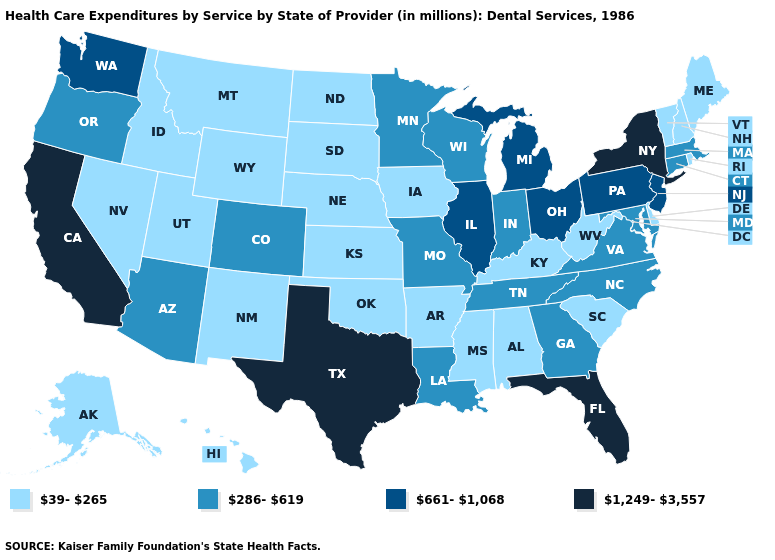Among the states that border Wisconsin , which have the lowest value?
Keep it brief. Iowa. Among the states that border Kentucky , which have the highest value?
Write a very short answer. Illinois, Ohio. Does Kansas have the highest value in the USA?
Give a very brief answer. No. Among the states that border South Dakota , does North Dakota have the lowest value?
Be succinct. Yes. What is the value of Arkansas?
Be succinct. 39-265. Among the states that border Wyoming , which have the lowest value?
Concise answer only. Idaho, Montana, Nebraska, South Dakota, Utah. Name the states that have a value in the range 661-1,068?
Short answer required. Illinois, Michigan, New Jersey, Ohio, Pennsylvania, Washington. Among the states that border Texas , does Louisiana have the lowest value?
Short answer required. No. Does Maine have a higher value than South Dakota?
Concise answer only. No. Which states have the lowest value in the West?
Be succinct. Alaska, Hawaii, Idaho, Montana, Nevada, New Mexico, Utah, Wyoming. Does Wisconsin have a lower value than Arkansas?
Short answer required. No. Name the states that have a value in the range 286-619?
Short answer required. Arizona, Colorado, Connecticut, Georgia, Indiana, Louisiana, Maryland, Massachusetts, Minnesota, Missouri, North Carolina, Oregon, Tennessee, Virginia, Wisconsin. Which states hav the highest value in the Northeast?
Concise answer only. New York. What is the value of Washington?
Quick response, please. 661-1,068. What is the lowest value in the West?
Give a very brief answer. 39-265. 